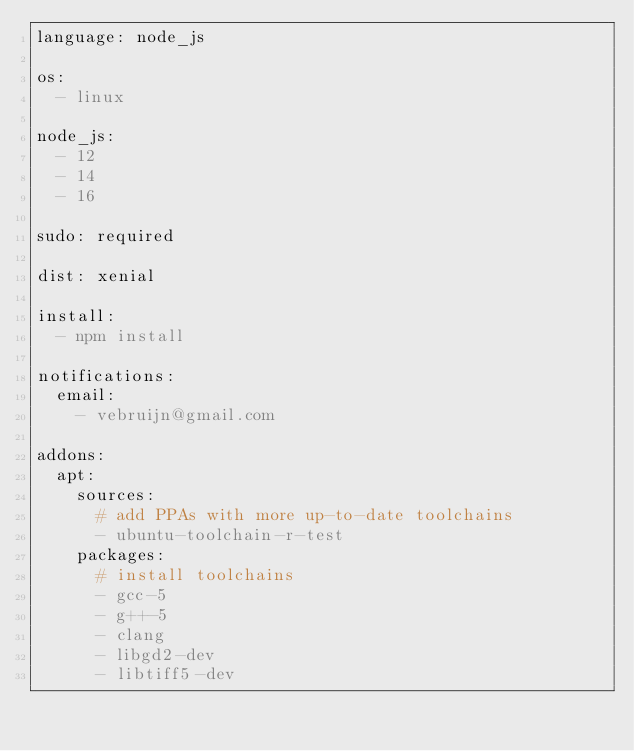Convert code to text. <code><loc_0><loc_0><loc_500><loc_500><_YAML_>language: node_js

os:
  - linux

node_js:
  - 12
  - 14
  - 16

sudo: required

dist: xenial

install:
  - npm install

notifications:
  email:
    - vebruijn@gmail.com

addons:
  apt:
    sources:
      # add PPAs with more up-to-date toolchains
      - ubuntu-toolchain-r-test
    packages:
      # install toolchains
      - gcc-5
      - g++-5
      - clang
      - libgd2-dev
      - libtiff5-dev
</code> 